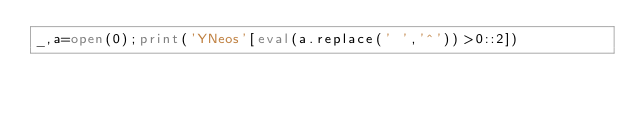<code> <loc_0><loc_0><loc_500><loc_500><_Python_>_,a=open(0);print('YNeos'[eval(a.replace(' ','^'))>0::2])</code> 